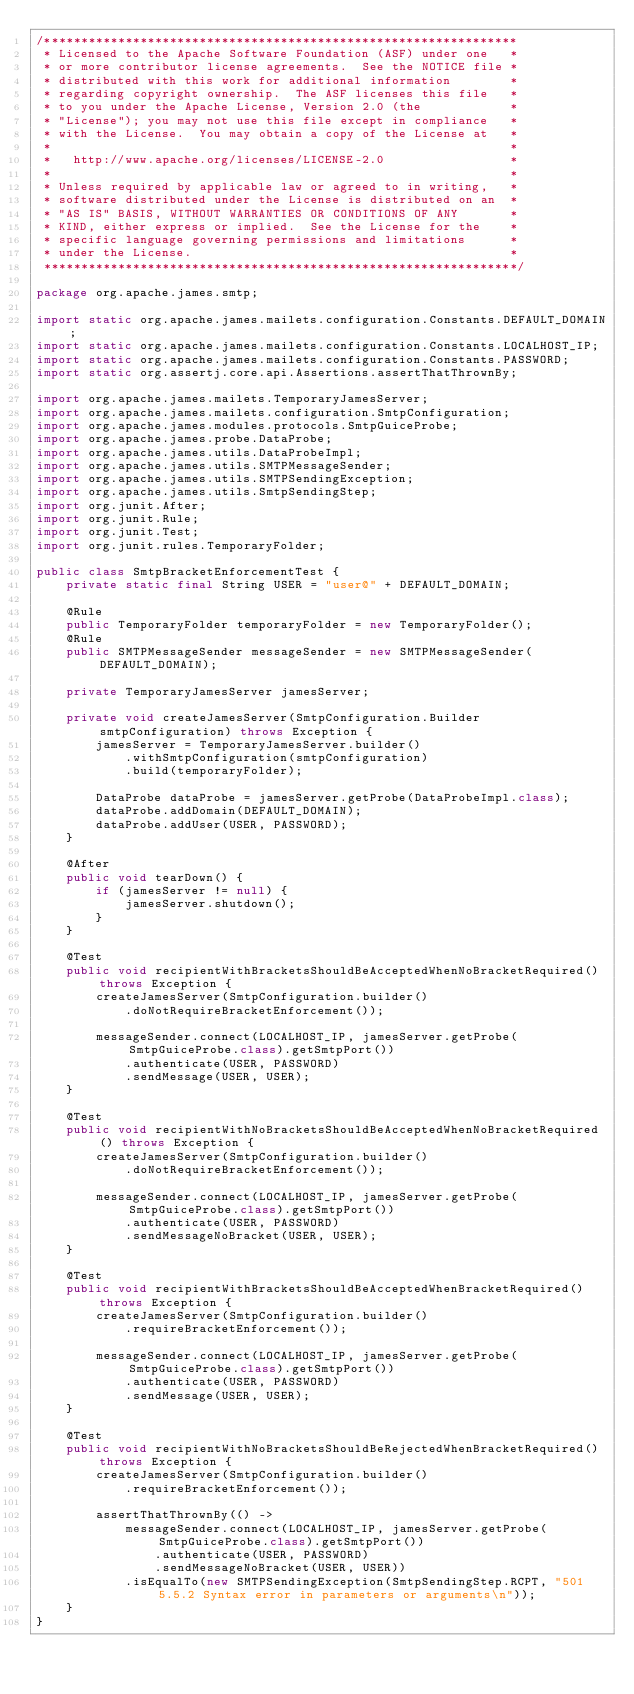<code> <loc_0><loc_0><loc_500><loc_500><_Java_>/****************************************************************
 * Licensed to the Apache Software Foundation (ASF) under one   *
 * or more contributor license agreements.  See the NOTICE file *
 * distributed with this work for additional information        *
 * regarding copyright ownership.  The ASF licenses this file   *
 * to you under the Apache License, Version 2.0 (the            *
 * "License"); you may not use this file except in compliance   *
 * with the License.  You may obtain a copy of the License at   *
 *                                                              *
 *   http://www.apache.org/licenses/LICENSE-2.0                 *
 *                                                              *
 * Unless required by applicable law or agreed to in writing,   *
 * software distributed under the License is distributed on an  *
 * "AS IS" BASIS, WITHOUT WARRANTIES OR CONDITIONS OF ANY       *
 * KIND, either express or implied.  See the License for the    *
 * specific language governing permissions and limitations      *
 * under the License.                                           *
 ****************************************************************/

package org.apache.james.smtp;

import static org.apache.james.mailets.configuration.Constants.DEFAULT_DOMAIN;
import static org.apache.james.mailets.configuration.Constants.LOCALHOST_IP;
import static org.apache.james.mailets.configuration.Constants.PASSWORD;
import static org.assertj.core.api.Assertions.assertThatThrownBy;

import org.apache.james.mailets.TemporaryJamesServer;
import org.apache.james.mailets.configuration.SmtpConfiguration;
import org.apache.james.modules.protocols.SmtpGuiceProbe;
import org.apache.james.probe.DataProbe;
import org.apache.james.utils.DataProbeImpl;
import org.apache.james.utils.SMTPMessageSender;
import org.apache.james.utils.SMTPSendingException;
import org.apache.james.utils.SmtpSendingStep;
import org.junit.After;
import org.junit.Rule;
import org.junit.Test;
import org.junit.rules.TemporaryFolder;

public class SmtpBracketEnforcementTest {
    private static final String USER = "user@" + DEFAULT_DOMAIN;

    @Rule
    public TemporaryFolder temporaryFolder = new TemporaryFolder();
    @Rule
    public SMTPMessageSender messageSender = new SMTPMessageSender(DEFAULT_DOMAIN);

    private TemporaryJamesServer jamesServer;

    private void createJamesServer(SmtpConfiguration.Builder smtpConfiguration) throws Exception {
        jamesServer = TemporaryJamesServer.builder()
            .withSmtpConfiguration(smtpConfiguration)
            .build(temporaryFolder);

        DataProbe dataProbe = jamesServer.getProbe(DataProbeImpl.class);
        dataProbe.addDomain(DEFAULT_DOMAIN);
        dataProbe.addUser(USER, PASSWORD);
    }

    @After
    public void tearDown() {
        if (jamesServer != null) {
            jamesServer.shutdown();
        }
    }

    @Test
    public void recipientWithBracketsShouldBeAcceptedWhenNoBracketRequired() throws Exception {
        createJamesServer(SmtpConfiguration.builder()
            .doNotRequireBracketEnforcement());

        messageSender.connect(LOCALHOST_IP, jamesServer.getProbe(SmtpGuiceProbe.class).getSmtpPort())
            .authenticate(USER, PASSWORD)
            .sendMessage(USER, USER);
    }

    @Test
    public void recipientWithNoBracketsShouldBeAcceptedWhenNoBracketRequired() throws Exception {
        createJamesServer(SmtpConfiguration.builder()
            .doNotRequireBracketEnforcement());

        messageSender.connect(LOCALHOST_IP, jamesServer.getProbe(SmtpGuiceProbe.class).getSmtpPort())
            .authenticate(USER, PASSWORD)
            .sendMessageNoBracket(USER, USER);
    }

    @Test
    public void recipientWithBracketsShouldBeAcceptedWhenBracketRequired() throws Exception {
        createJamesServer(SmtpConfiguration.builder()
            .requireBracketEnforcement());

        messageSender.connect(LOCALHOST_IP, jamesServer.getProbe(SmtpGuiceProbe.class).getSmtpPort())
            .authenticate(USER, PASSWORD)
            .sendMessage(USER, USER);
    }

    @Test
    public void recipientWithNoBracketsShouldBeRejectedWhenBracketRequired() throws Exception {
        createJamesServer(SmtpConfiguration.builder()
            .requireBracketEnforcement());

        assertThatThrownBy(() ->
            messageSender.connect(LOCALHOST_IP, jamesServer.getProbe(SmtpGuiceProbe.class).getSmtpPort())
                .authenticate(USER, PASSWORD)
                .sendMessageNoBracket(USER, USER))
            .isEqualTo(new SMTPSendingException(SmtpSendingStep.RCPT, "501 5.5.2 Syntax error in parameters or arguments\n"));
    }
}
</code> 